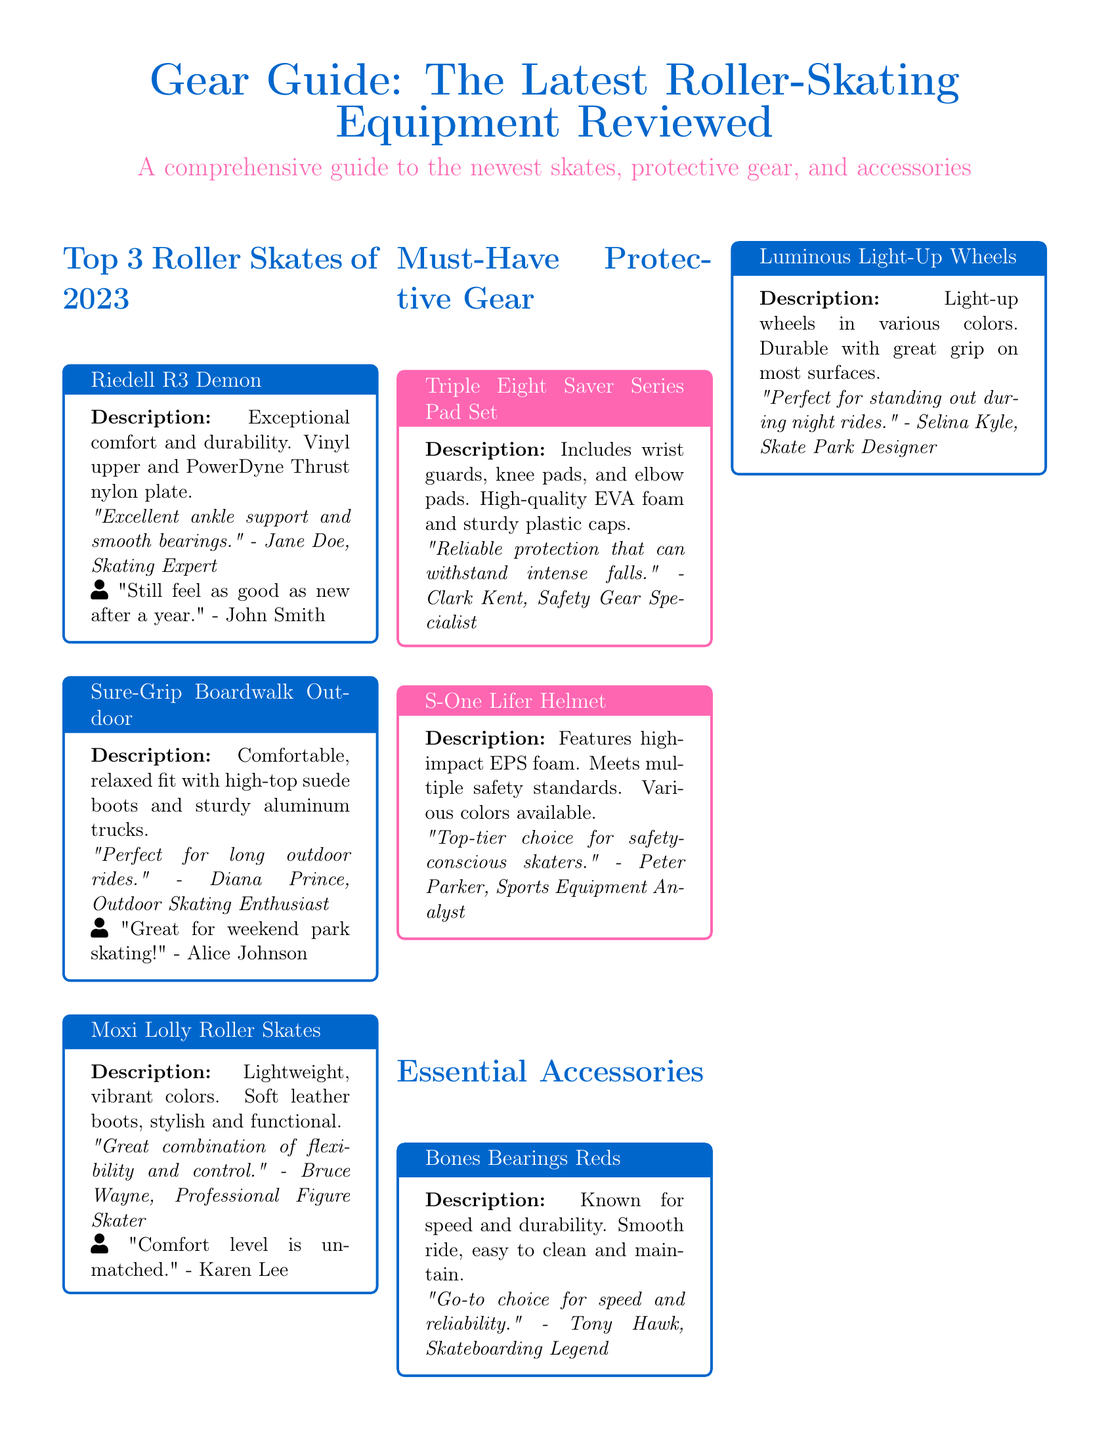What are the top 3 roller skates of 2023? The top 3 roller skates listed in the document are Riedell R3 Demon, Sure-Grip Boardwalk Outdoor, and Moxi Lolly Roller Skates.
Answer: Riedell R3 Demon, Sure-Grip Boardwalk Outdoor, Moxi Lolly Roller Skates What material are the boots of Moxi Lolly Roller Skates made from? The document states that Moxi Lolly Roller Skates have soft leather boots.
Answer: Soft leather Who reviewed the Sure-Grip Boardwalk Outdoor skates? The document includes a review by Diana Prince, who is an outdoor skating enthusiast.
Answer: Diana Prince What is included in the Triple Eight Saver Series Pad Set? The document mentions that the set includes wrist guards, knee pads, and elbow pads.
Answer: Wrist guards, knee pads, elbow pads How many colors does the S-One Lifer Helmet come in? According to the document, the S-One Lifer Helmet comes in various colors.
Answer: Various colors What is the main feature of the Luminous Light-Up Wheels? The document highlights that these wheels light up in various colors.
Answer: Light-up in various colors Which skate is described as having a relaxed fit? The Sure-Grip Boardwalk Outdoor skates are described as having a comfortable, relaxed fit.
Answer: Sure-Grip Boardwalk Outdoor What type of foam is used in the S-One Lifer Helmet? The document specifies that the helmet features high-impact EPS foam.
Answer: High-impact EPS foam 